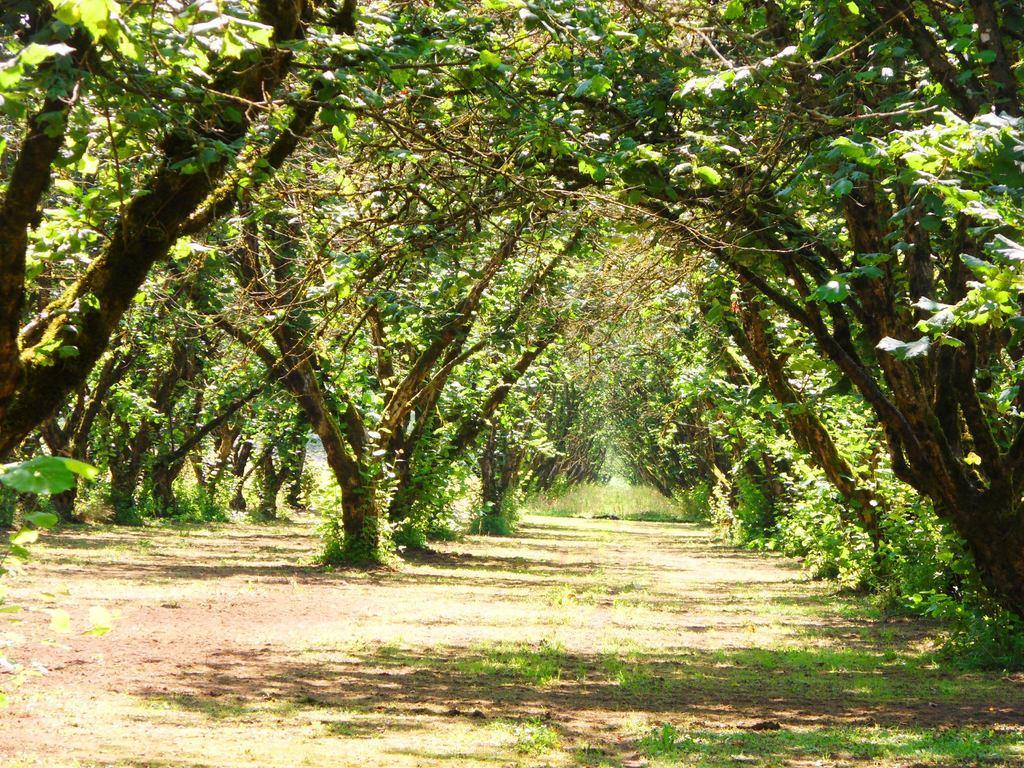Please provide a concise description of this image. In this image we can see trees, plants and ground. 